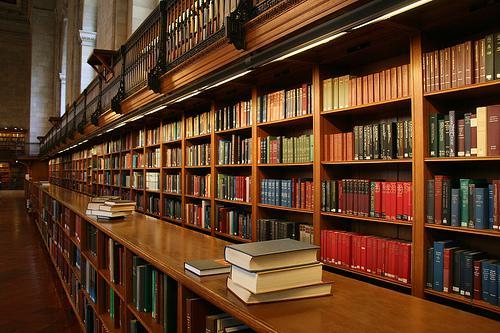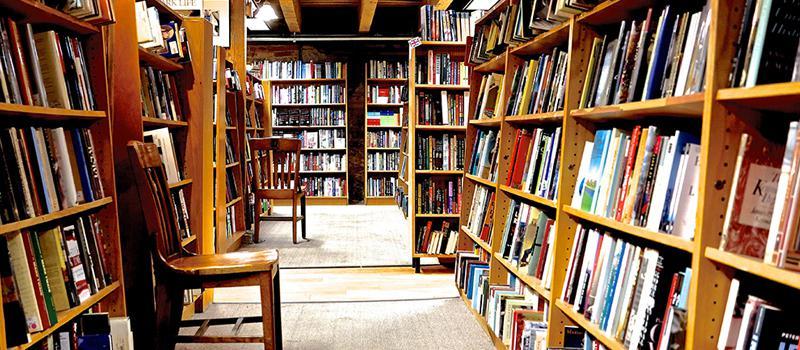The first image is the image on the left, the second image is the image on the right. Given the left and right images, does the statement "In at least one image there is an empty bookstore  with table that has at least 30 books on it." hold true? Answer yes or no. No. The first image is the image on the left, the second image is the image on the right. For the images displayed, is the sentence "In the image on the right, there is at least one table that holds some books propped up on bookstands." factually correct? Answer yes or no. No. 